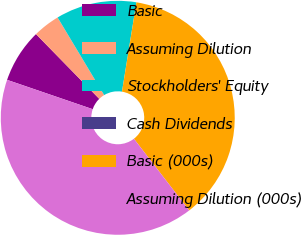Convert chart to OTSL. <chart><loc_0><loc_0><loc_500><loc_500><pie_chart><fcel>Basic<fcel>Assuming Dilution<fcel>Stockholders' Equity<fcel>Cash Dividends<fcel>Basic (000s)<fcel>Assuming Dilution (000s)<nl><fcel>7.43%<fcel>3.72%<fcel>11.15%<fcel>0.0%<fcel>37.0%<fcel>40.71%<nl></chart> 